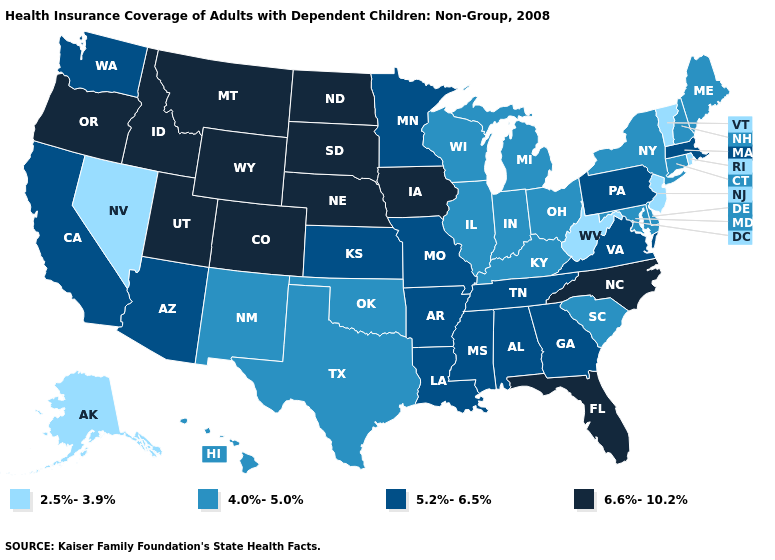What is the value of Wyoming?
Keep it brief. 6.6%-10.2%. Does Rhode Island have the lowest value in the USA?
Concise answer only. Yes. Among the states that border Michigan , which have the highest value?
Concise answer only. Indiana, Ohio, Wisconsin. What is the value of Minnesota?
Short answer required. 5.2%-6.5%. What is the value of Montana?
Concise answer only. 6.6%-10.2%. Which states have the lowest value in the USA?
Give a very brief answer. Alaska, Nevada, New Jersey, Rhode Island, Vermont, West Virginia. Name the states that have a value in the range 2.5%-3.9%?
Write a very short answer. Alaska, Nevada, New Jersey, Rhode Island, Vermont, West Virginia. Among the states that border Delaware , does Pennsylvania have the highest value?
Give a very brief answer. Yes. What is the value of Nebraska?
Short answer required. 6.6%-10.2%. Which states have the highest value in the USA?
Give a very brief answer. Colorado, Florida, Idaho, Iowa, Montana, Nebraska, North Carolina, North Dakota, Oregon, South Dakota, Utah, Wyoming. Does Rhode Island have the lowest value in the Northeast?
Concise answer only. Yes. Which states have the lowest value in the USA?
Give a very brief answer. Alaska, Nevada, New Jersey, Rhode Island, Vermont, West Virginia. Does Missouri have the highest value in the MidWest?
Short answer required. No. Name the states that have a value in the range 4.0%-5.0%?
Be succinct. Connecticut, Delaware, Hawaii, Illinois, Indiana, Kentucky, Maine, Maryland, Michigan, New Hampshire, New Mexico, New York, Ohio, Oklahoma, South Carolina, Texas, Wisconsin. 